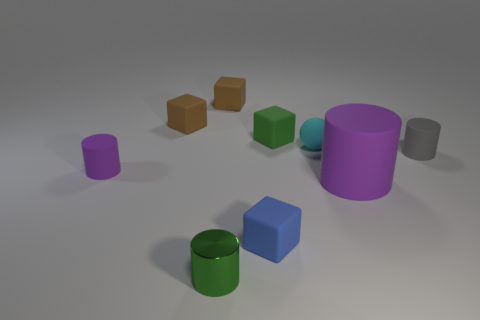Is the number of tiny brown matte blocks that are in front of the small cyan ball less than the number of tiny rubber blocks in front of the tiny gray cylinder?
Your answer should be very brief. Yes. Are there any small green objects behind the tiny purple object?
Give a very brief answer. Yes. There is a small gray matte thing that is behind the purple rubber cylinder that is on the right side of the tiny metal cylinder; are there any matte cylinders that are on the left side of it?
Offer a very short reply. Yes. Is the shape of the object that is in front of the blue matte thing the same as  the tiny cyan rubber thing?
Your response must be concise. No. There is a big cylinder that is the same material as the ball; what color is it?
Your answer should be compact. Purple. What number of tiny blue blocks have the same material as the ball?
Offer a terse response. 1. What is the color of the block that is in front of the matte cylinder behind the purple thing on the left side of the cyan matte ball?
Offer a very short reply. Blue. Is there anything else that is the same shape as the small cyan object?
Ensure brevity in your answer.  No. How many things are either purple objects that are on the left side of the blue rubber object or large gray objects?
Give a very brief answer. 1. Is the shape of the tiny shiny object the same as the large object?
Provide a succinct answer. Yes. 